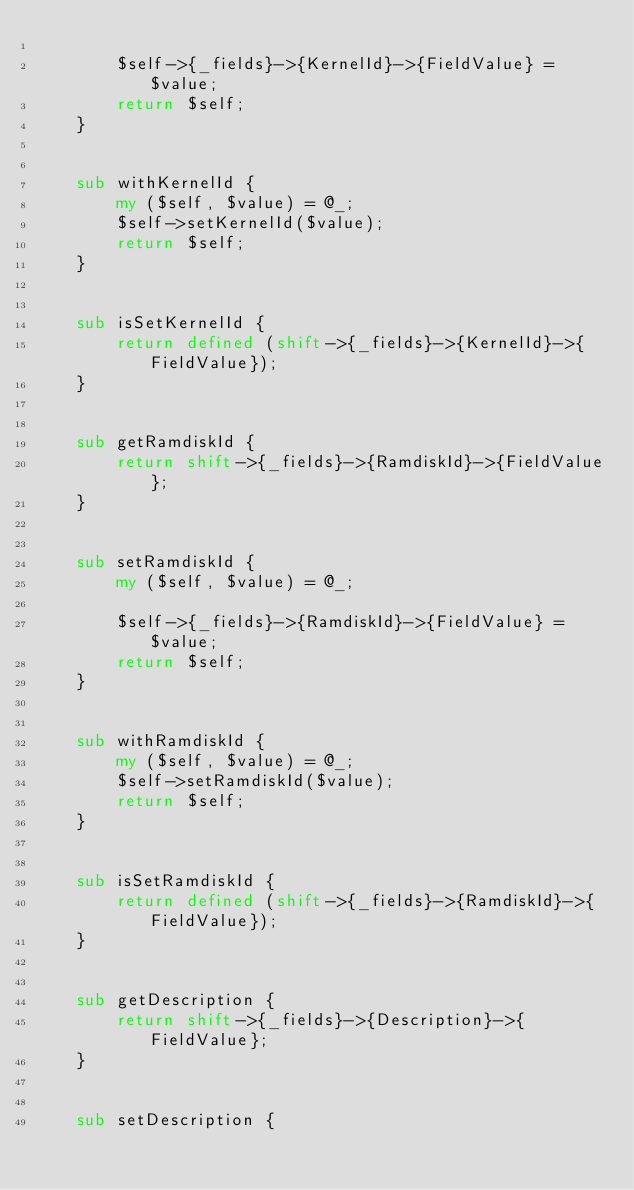Convert code to text. <code><loc_0><loc_0><loc_500><loc_500><_Perl_>
        $self->{_fields}->{KernelId}->{FieldValue} = $value;
        return $self;
    }


    sub withKernelId {
        my ($self, $value) = @_;
        $self->setKernelId($value);
        return $self;
    }


    sub isSetKernelId {
        return defined (shift->{_fields}->{KernelId}->{FieldValue});
    }


    sub getRamdiskId {
        return shift->{_fields}->{RamdiskId}->{FieldValue};
    }


    sub setRamdiskId {
        my ($self, $value) = @_;

        $self->{_fields}->{RamdiskId}->{FieldValue} = $value;
        return $self;
    }


    sub withRamdiskId {
        my ($self, $value) = @_;
        $self->setRamdiskId($value);
        return $self;
    }


    sub isSetRamdiskId {
        return defined (shift->{_fields}->{RamdiskId}->{FieldValue});
    }


    sub getDescription {
        return shift->{_fields}->{Description}->{FieldValue};
    }


    sub setDescription {</code> 